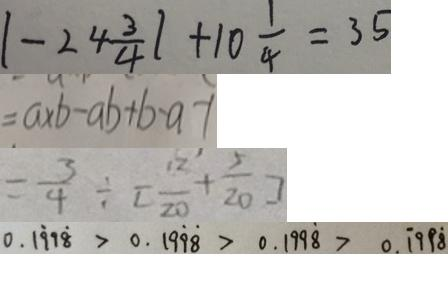Convert formula to latex. <formula><loc_0><loc_0><loc_500><loc_500>\vert - 2 4 \frac { 3 } { 4 } \vert + 1 0 \frac { 1 } { 4 } = 3 5 
 = a \times b - a b + b - a - 1 
 = \frac { 3 } { 4 } \div [ \frac { 1 2 } { 2 0 } + \frac { 5 } { 2 0 } ] 
 0 . 1 \dot { 9 } 9 \dot { 8 } > 0 . 1 9 \dot { 9 } \dot { 8 } > 0 . 1 9 9 \dot { 8 } > 0 . \dot { 1 } 9 9 \dot { 8 }</formula> 